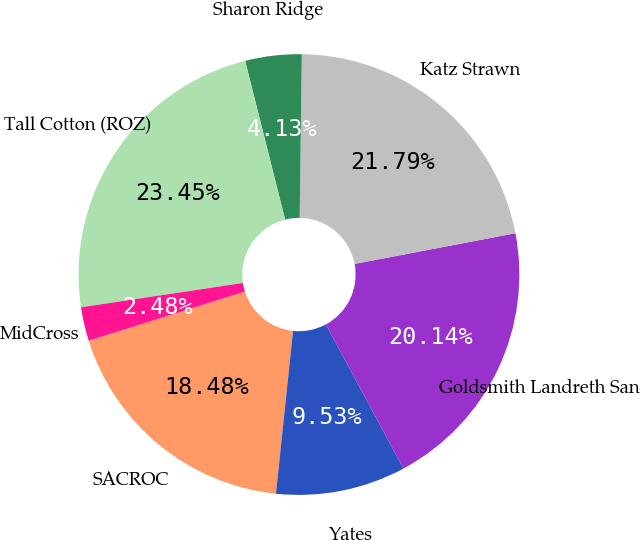<chart> <loc_0><loc_0><loc_500><loc_500><pie_chart><fcel>SACROC<fcel>Yates<fcel>Goldsmith Landreth San<fcel>Katz Strawn<fcel>Sharon Ridge<fcel>Tall Cotton (ROZ)<fcel>MidCross<nl><fcel>18.48%<fcel>9.53%<fcel>20.14%<fcel>21.79%<fcel>4.13%<fcel>23.45%<fcel>2.48%<nl></chart> 